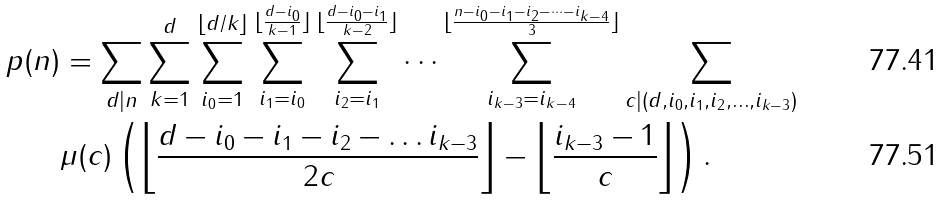<formula> <loc_0><loc_0><loc_500><loc_500>p ( n ) & = \sum _ { d | n } \sum _ { k = 1 } ^ { d } \sum _ { i _ { 0 } = 1 } ^ { \lfloor d / k \rfloor } \sum _ { i _ { 1 } = i _ { 0 } } ^ { \lfloor \frac { d - i _ { 0 } } { k - 1 } \rfloor } \sum _ { i _ { 2 } = i _ { 1 } } ^ { \lfloor \frac { d - i _ { 0 } - i _ { 1 } } { k - 2 } \rfloor } \dots \sum _ { i _ { k - 3 } = i _ { k - 4 } } ^ { \lfloor \frac { n - i _ { 0 } - i _ { 1 } - i _ { 2 } - \dots - i _ { k - 4 } } { 3 } \rfloor } \sum _ { c | ( d , i _ { 0 } , i _ { 1 } , i _ { 2 } , \dots , i _ { k - 3 } ) } \\ & \mu ( c ) \left ( \left \lfloor \frac { d - i _ { 0 } - i _ { 1 } - i _ { 2 } - \dots i _ { k - 3 } } { 2 c } \right \rfloor - \left \lfloor \frac { i _ { k - 3 } - 1 } { c } \right \rfloor \right ) .</formula> 